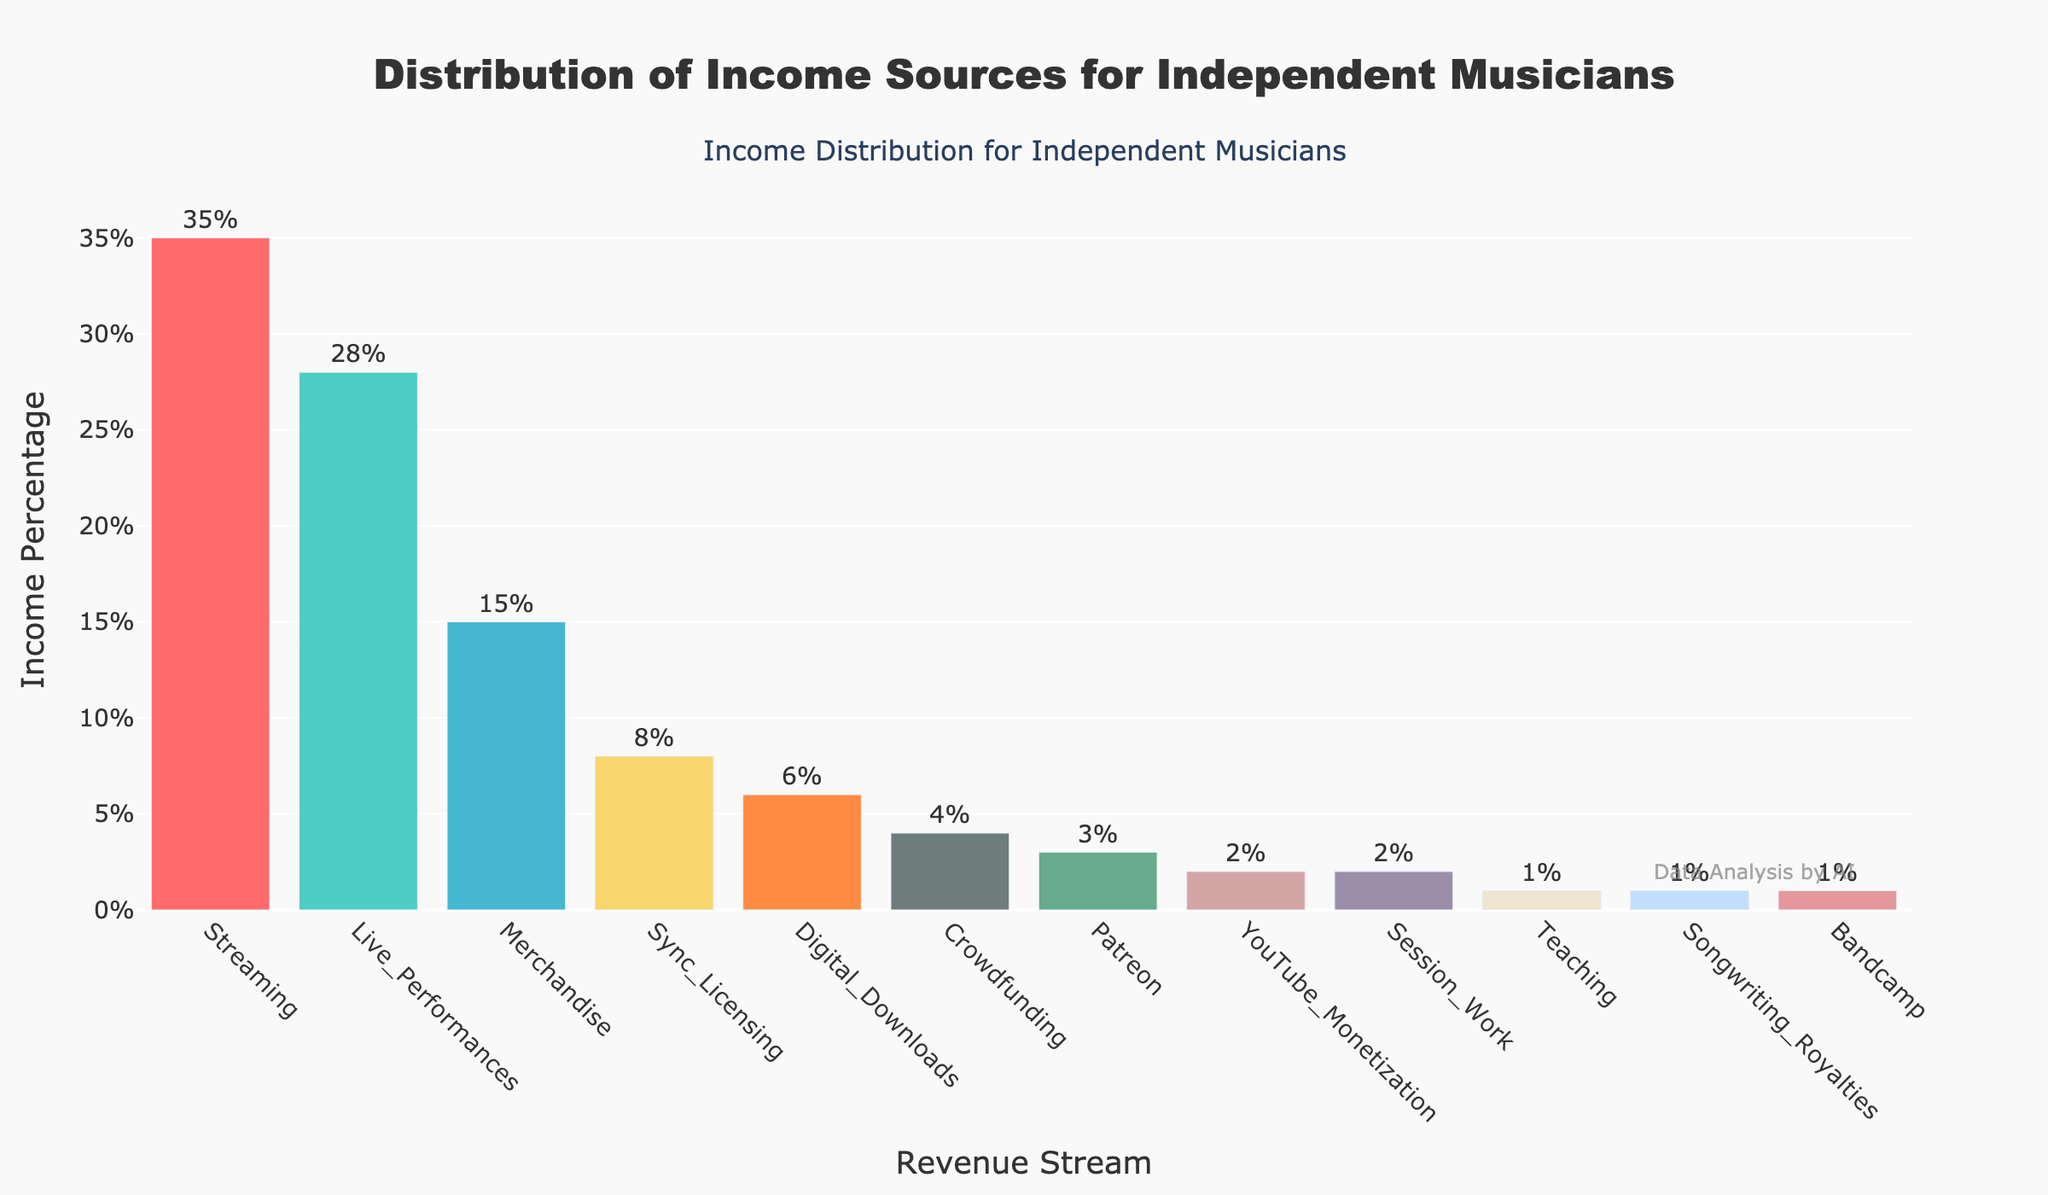Which revenue stream contributes the most to income for independent musicians? Look at the bar chart and identify the bar with the highest value. The 'Streaming' revenue stream has the highest income percentage.
Answer: Streaming What is the percentage of income from live performances? Identify the bar labeled 'Live_Performances' and read its corresponding value. The percentage of income from live performances is shown as 28%.
Answer: 28% How many different revenue streams are shown in the plot? Count the total number of bars in the chart. The labeled bars indicate there are 12 revenue streams.
Answer: 12 What's the combined income percentage from Streaming and Live Performances? Find the percentages for 'Streaming' and 'Live_Performances' and add them together: 35% + 28%. Thus, the combined percentage is 63%.
Answer: 63% Which revenue stream contributes the least to income? Look for the bar with the smallest value. The 'Teaching', 'Songwriting_Royalties', and 'Bandcamp' streams each have 1%, which are the smallest.
Answer: Teaching, Songwriting_Royalties, Bandcamp How much more income percentage does merchandise generate compared to digital downloads? Identify the values for 'Merchandise' (15%) and 'Digital_Downloads' (6%). Subtract the smaller percentage from the larger one: 15% - 6%. The difference is 9%.
Answer: 9% What's the percentage difference between Patreon and YouTube Monetization? Locate the bars for 'Patreon' (3%) and 'YouTube_Monetization' (2%). Subtract the lower value from the higher one: 3% - 2%. The percentage difference is 1%.
Answer: 1% What is the total percentage of income from those streams contributing less than 5% each? Identify the streams with less than 5%: Sync_Licensing (8%), Digital_Downloads (6%), Crowdfunding (4%), Patreon (3%), YouTube_Monetization (2%), Session_Work (2%), Teaching (1%), Songwriting_Royalties (1%), Bandcamp (1%). Sum their percentages: 4% + 3% + 2% + 2% + 1% + 1% + 1% = 14%.
Answer: 14% Which revenue stream is closest in income percentage to crowdfunding? Identify the income percentage for 'Crowdfunding' (4%) and look for the stream with a similar value, which is 'Patreon' at 3%.
Answer: Patreon 